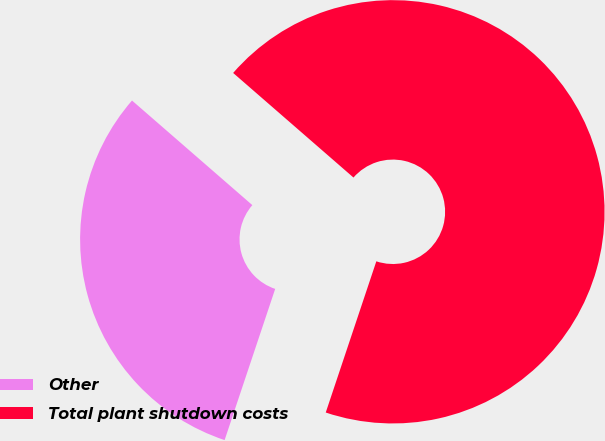<chart> <loc_0><loc_0><loc_500><loc_500><pie_chart><fcel>Other<fcel>Total plant shutdown costs<nl><fcel>31.25%<fcel>68.75%<nl></chart> 